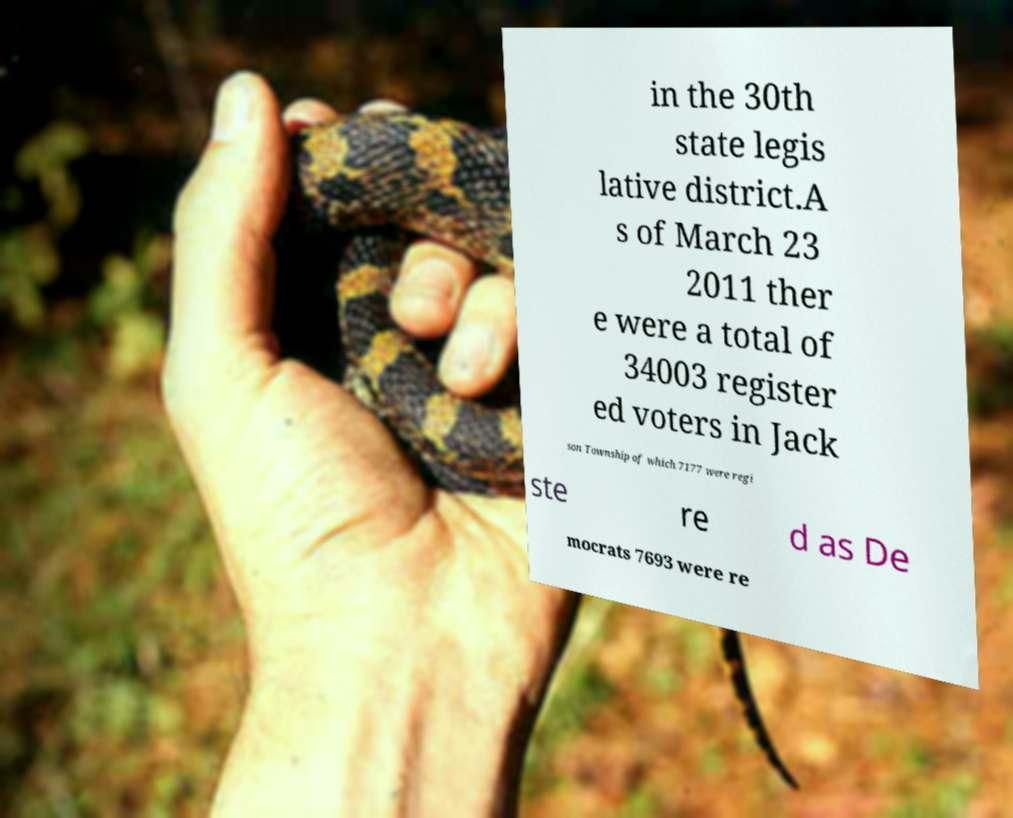Can you accurately transcribe the text from the provided image for me? in the 30th state legis lative district.A s of March 23 2011 ther e were a total of 34003 register ed voters in Jack son Township of which 7177 were regi ste re d as De mocrats 7693 were re 